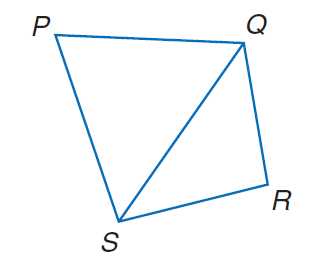Question: In quadrilateral P Q R S, P Q = 721, Q R = 547, R S = 593, P S = 756, and m \angle P = 58. Find Q S.
Choices:
A. 345.7
B. 542.5
C. 671.2
D. 716.7
Answer with the letter. Answer: D Question: In quadrilateral P Q R S, P Q = 721, Q R = 547, R S = 593, P S = 756, and m \angle P = 58. Find m \angle R.
Choices:
A. 53.4
B. 67.4
C. 77.8
D. 87.6
Answer with the letter. Answer: C 